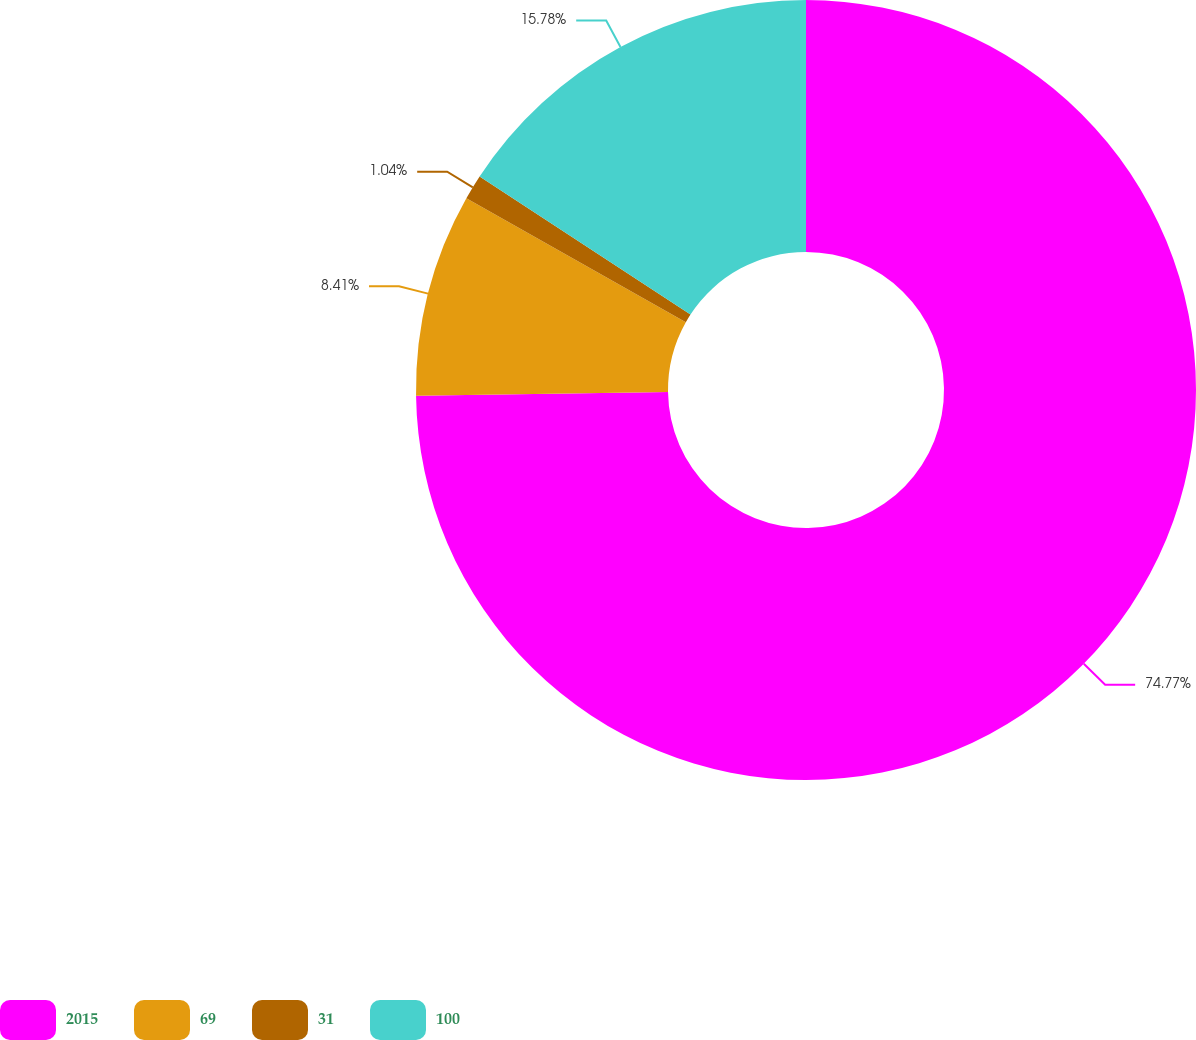Convert chart. <chart><loc_0><loc_0><loc_500><loc_500><pie_chart><fcel>2015<fcel>69<fcel>31<fcel>100<nl><fcel>74.76%<fcel>8.41%<fcel>1.04%<fcel>15.78%<nl></chart> 